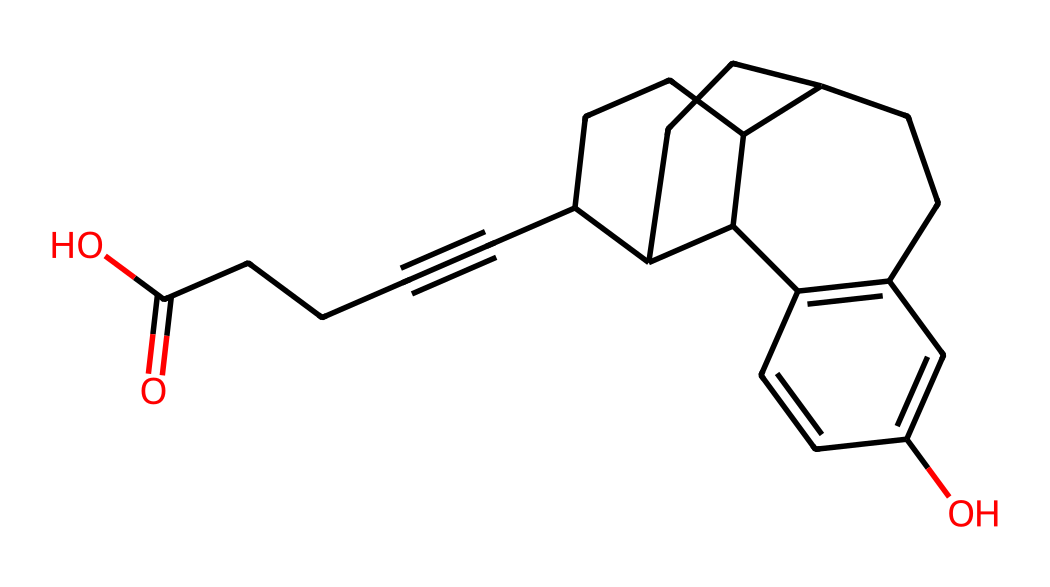How many carbon atoms are present in this chemical structure? To determine the number of carbon atoms, count each carbon symbol (C) in the SMILES representation. Upon inspection, there are 17 carbon atoms counted from the structure.
Answer: 17 What functional groups are present in this chemical? Analyzing the chemical structure reveals an acid group (carboxylic acid) indicated by the presence of the -COOH. Also, there’s an alcohol group (due to the -OH). So, the functional groups present are carboxylic acid and alcohol.
Answer: carboxylic acid, alcohol What is the molecular formula for the chemical represented by this SMILES? To derive the molecular formula, add up all atoms as indicated in the structure: 17 carbon (C), 26 hydrogen (H), and 3 oxygen (O), leading to the molecular formula C17H26O3.
Answer: C17H26O3 Does this chemical likely have steric hindrance based on its structure? The structure comprises multiple bulky groups (cycloalkane rings) and substituents, indicating that steric hindrance is probable due to crowding around certain atoms.
Answer: Yes What type of reaction could be used to synthesize this compound? Given the presence of functional groups and rings, a suitable method could be a multi-step synthesis involving cyclization and functional group reactions. Common reactions include Friedel-Crafts acylation or alkylation, but specific details depend on synthetic route.
Answer: Multi-step synthesis Which type of drug could this chemical potentially represent? Based on the chemical structure and presence of specific functional groups, this compound resembles a steroid or hormone, thus suggesting it could be a gender-affirming hormone treatment.
Answer: Hormone 